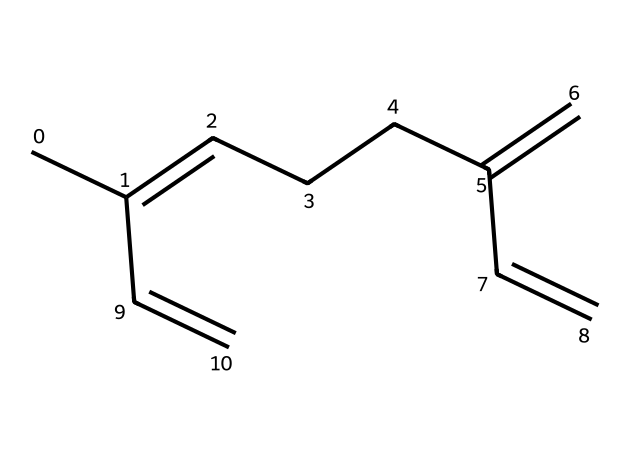What is the molecular formula of myrcene? To determine the molecular formula, count the number of each type of atom in the SMILES representation. The SMILES CC(=CCCC(=C)C=C) indicates there are 10 carbon atoms and 16 hydrogen atoms. Therefore, the molecular formula is C10H16.
Answer: C10H16 How many double bonds are present in myrcene? In the SMILES representation CC(=CCCC(=C)C=C), the "C=" symbols indicate double bonds. By counting them, we can see there are a total of 3 double bonds in the structure.
Answer: 3 What is the primary functional group in myrcene? Looking at the SMILES representation, we identify that myrcene consists of carbon and hydrogen atoms with double bonds present, which classifies it as an alkene. There are no other distinct functional groups present.
Answer: alkene What is the boiling point range for myrcene? Myrcene typically has a boiling point of around 166-170 degrees Celsius. This can be derived from general knowledge of terpenes, particularly myrcene’s known properties.
Answer: 166-170 °C What characteristic scent is associated with myrcene? Myrcene is known for its earthy and fruity aroma, which is a characterization of its natural scent profile found in cannabis and certain hops.
Answer: earthy and fruity How many rings or cycles are in the structure of myrcene? The SMILES representation CC(=CCCC(=C)C=C) displays a linear structure with no cyclic components; therefore, there are zero rings in myrcene.
Answer: 0 Is myrcene considered a monoterpene or sesquiterpene? Based on the structure of myrcene, which consists of 10 carbon atoms, it categorizes myrcene as a monoterpene (compared to sesquiterpenes that have 15 carbon atoms).
Answer: monoterpene 